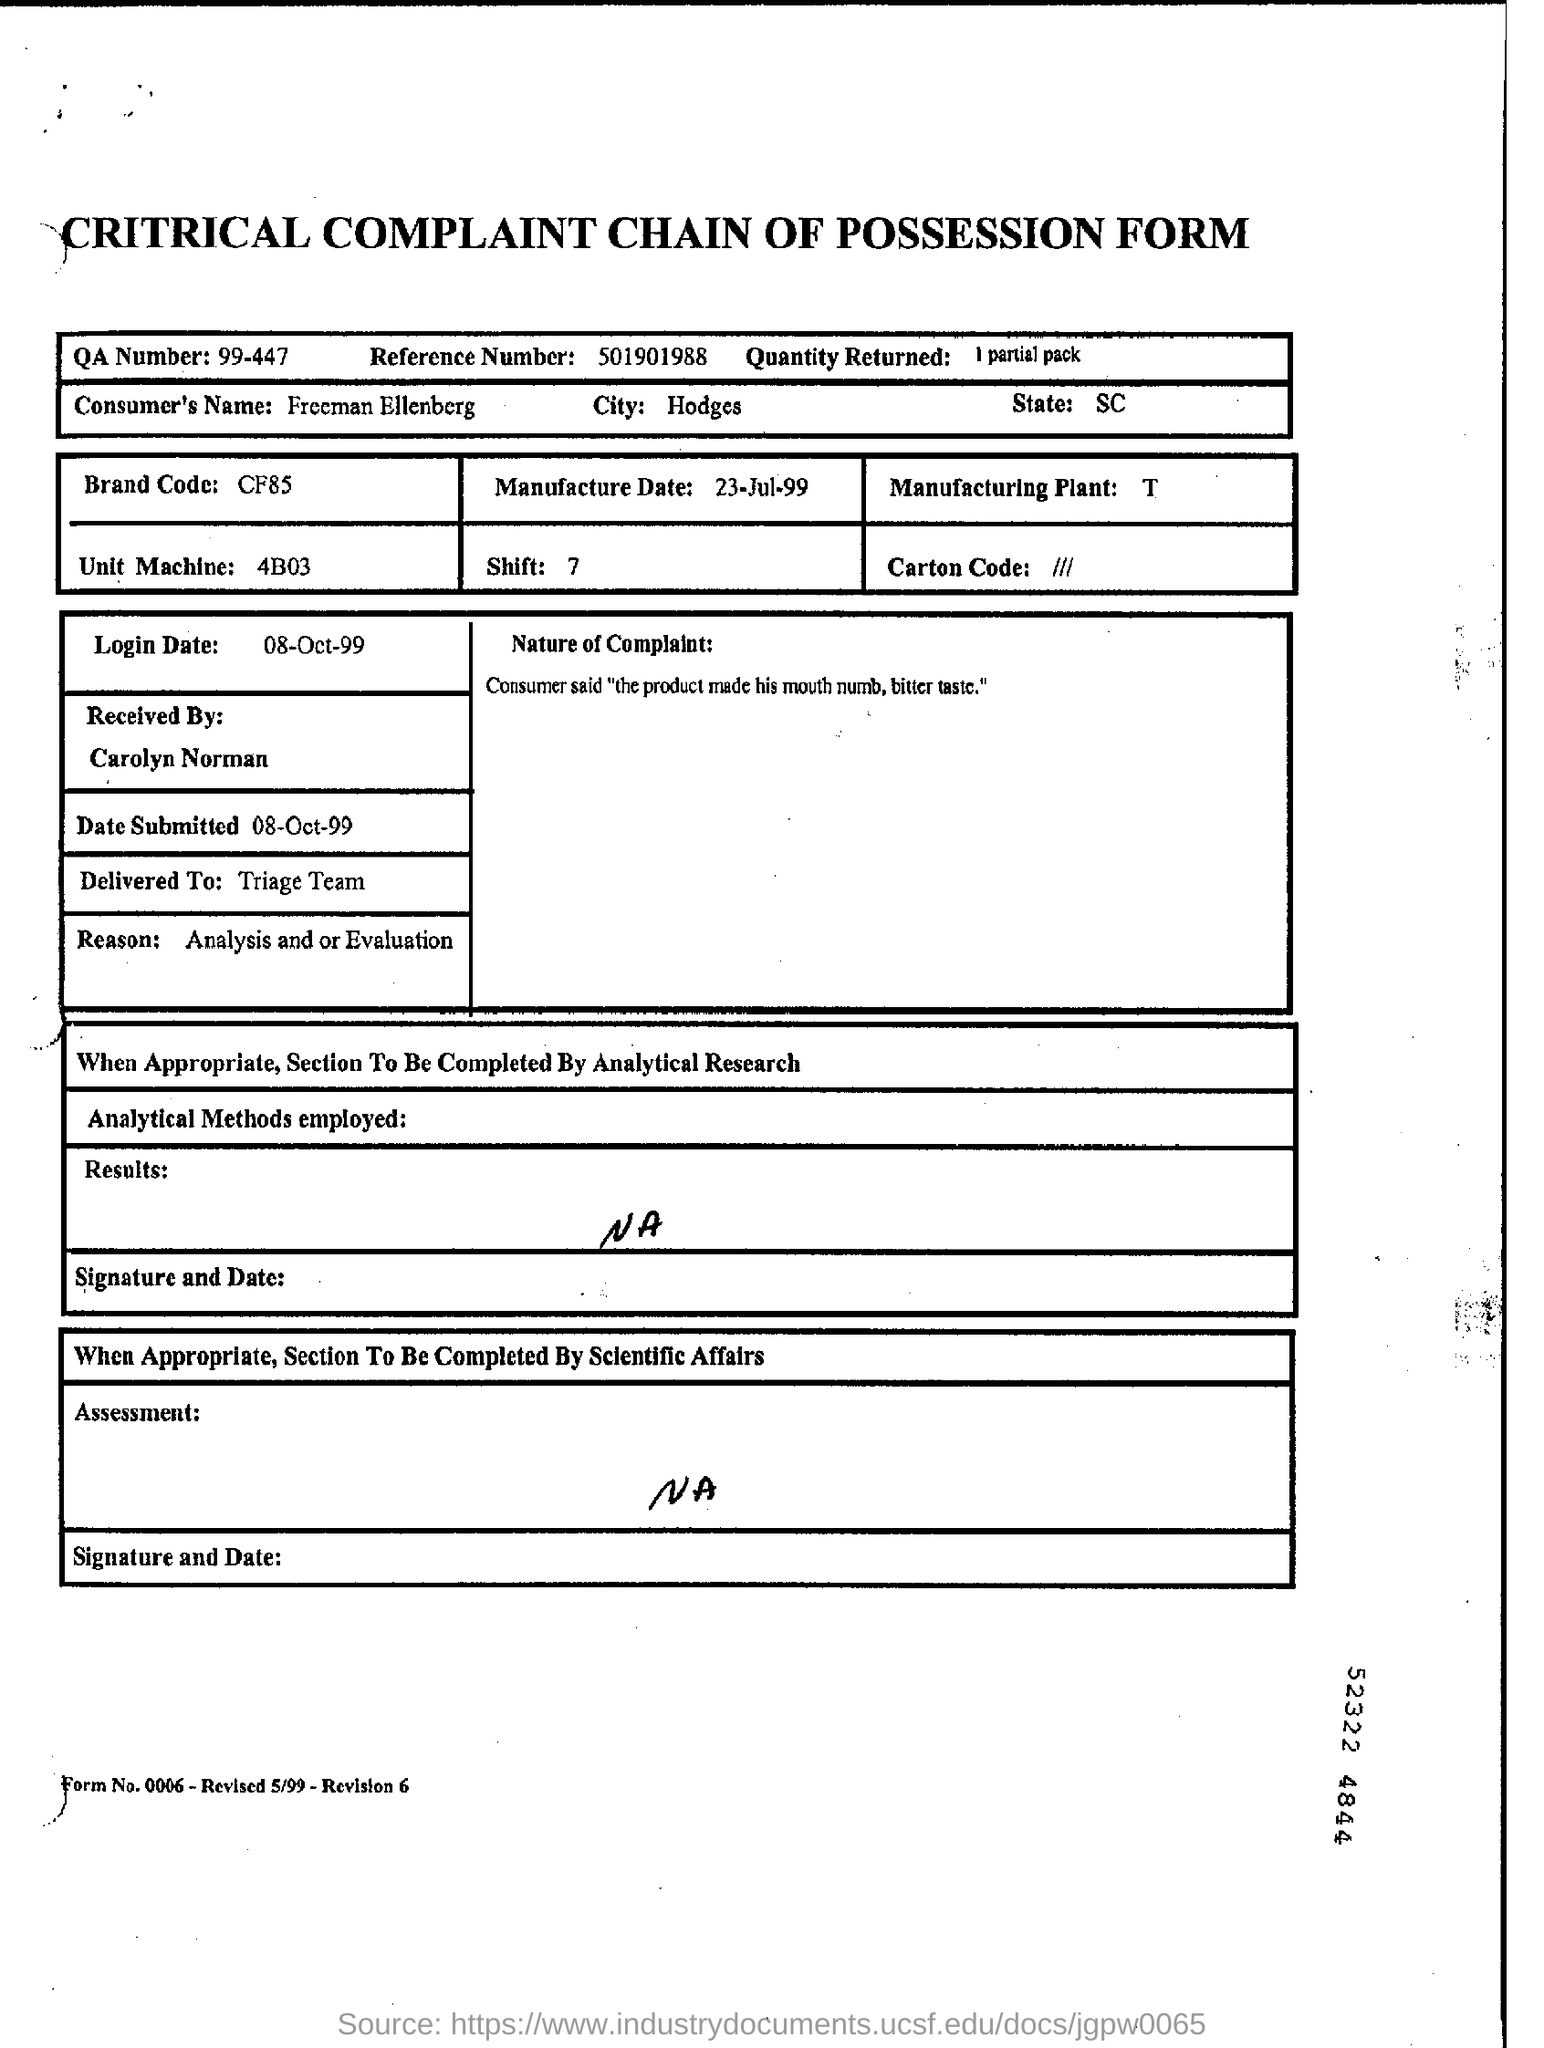What is the QA number?
Offer a very short reply. 99-447. What is the reference number given?
Offer a very short reply. 501901988. What was the quantity returned?
Your answer should be compact. 1 partial pack. What is the consumer's name?
Make the answer very short. Freeman Ellenberg. What is the brand code?
Give a very brief answer. CF85. Which was the unit machine?
Your answer should be very brief. 4B03. 